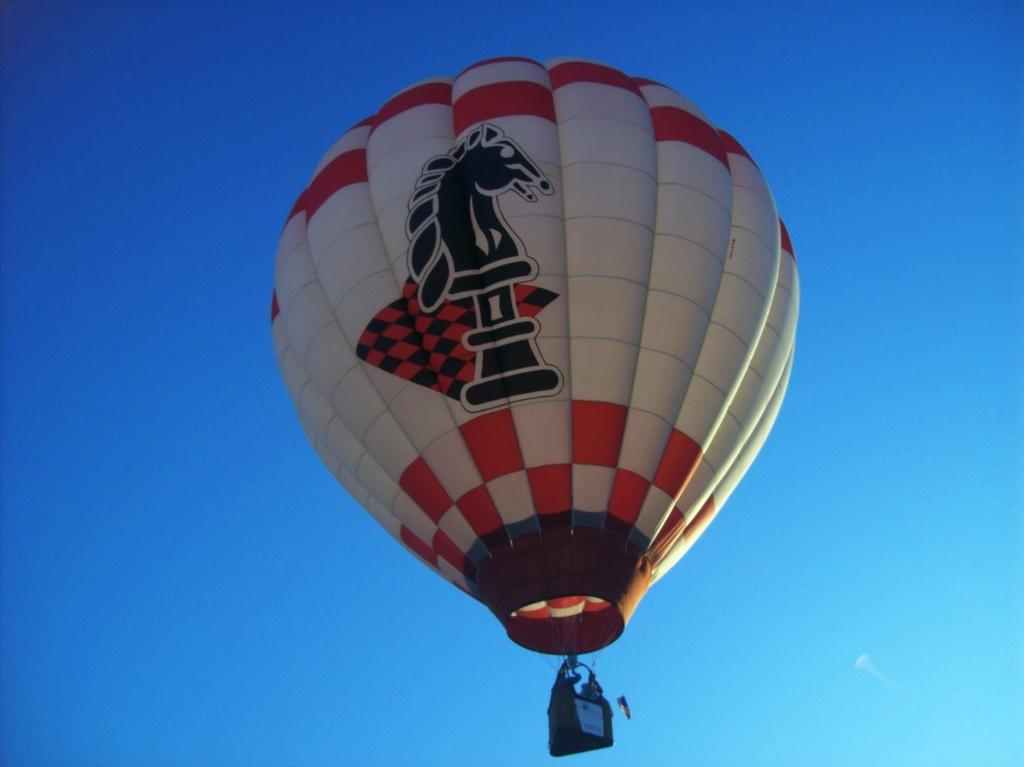What is the main subject of the image? There is a hot air balloon in the image. What can be seen in the background of the image? The sky is visible in the background of the image. What color is the sky in the image? The sky is blue in the image. Can you see any cows grazing in the field below the hot air balloon in the image? There is no field or cows present in the image; it only features a hot air balloon and the blue sky. 